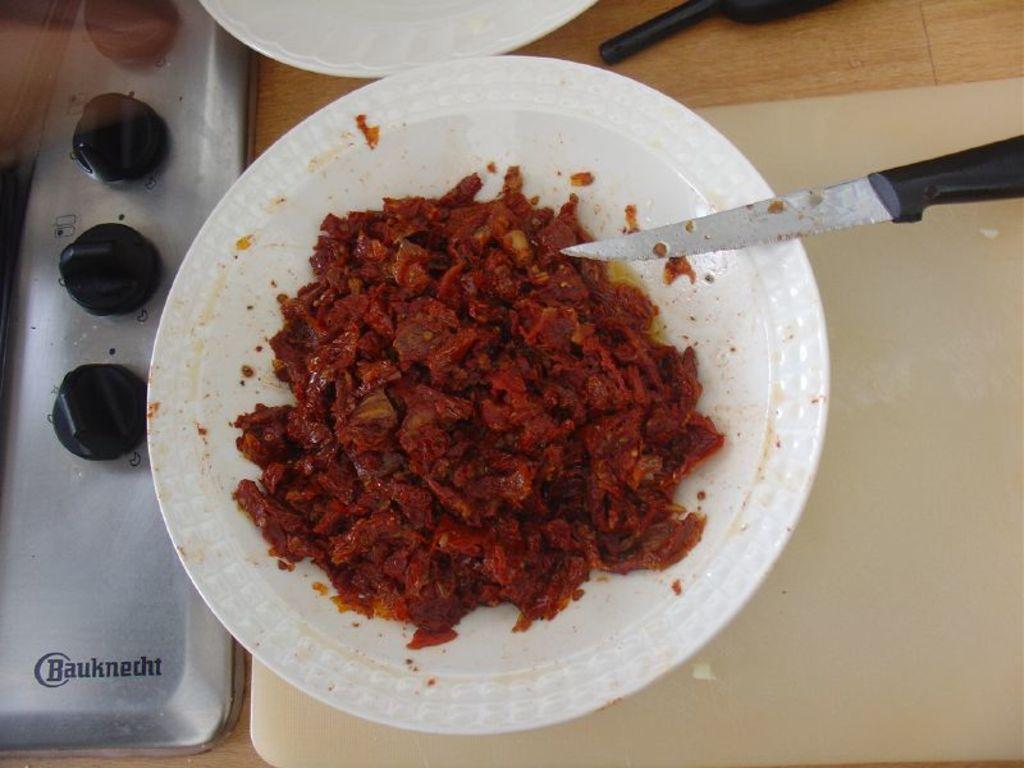Please provide a concise description of this image. Here I can see a table on which a cutting board, knife, two plates, stove and other objects are placed. On the plate, I can see some food item. 